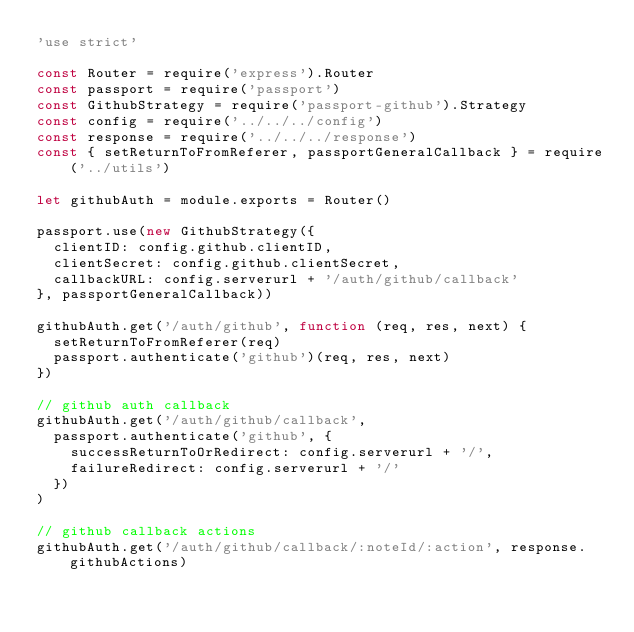Convert code to text. <code><loc_0><loc_0><loc_500><loc_500><_JavaScript_>'use strict'

const Router = require('express').Router
const passport = require('passport')
const GithubStrategy = require('passport-github').Strategy
const config = require('../../../config')
const response = require('../../../response')
const { setReturnToFromReferer, passportGeneralCallback } = require('../utils')

let githubAuth = module.exports = Router()

passport.use(new GithubStrategy({
  clientID: config.github.clientID,
  clientSecret: config.github.clientSecret,
  callbackURL: config.serverurl + '/auth/github/callback'
}, passportGeneralCallback))

githubAuth.get('/auth/github', function (req, res, next) {
  setReturnToFromReferer(req)
  passport.authenticate('github')(req, res, next)
})

// github auth callback
githubAuth.get('/auth/github/callback',
  passport.authenticate('github', {
    successReturnToOrRedirect: config.serverurl + '/',
    failureRedirect: config.serverurl + '/'
  })
)

// github callback actions
githubAuth.get('/auth/github/callback/:noteId/:action', response.githubActions)
</code> 